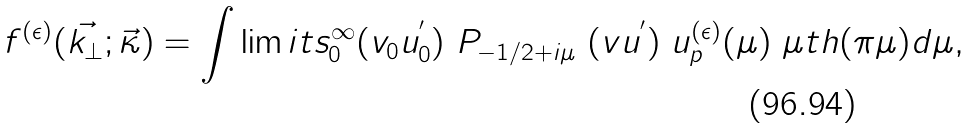<formula> <loc_0><loc_0><loc_500><loc_500>f ^ { ( \epsilon ) } ( \vec { k _ { \bot } } ; \vec { \kappa } ) = \int \lim i t s _ { 0 } ^ { \infty } ( v _ { 0 } u ^ { ^ { \prime } } _ { 0 } ) \ P _ { - 1 / 2 + i \mu } \ ( v u ^ { ^ { \prime } } ) \ u _ { p } ^ { ( \epsilon ) } ( \mu ) \ \mu t h ( \pi \mu ) d \mu ,</formula> 